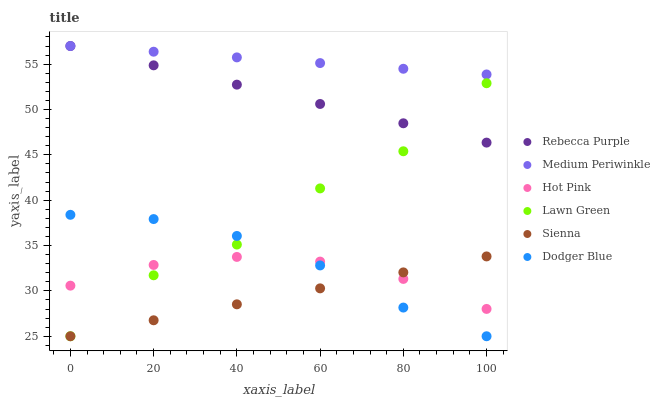Does Sienna have the minimum area under the curve?
Answer yes or no. Yes. Does Medium Periwinkle have the maximum area under the curve?
Answer yes or no. Yes. Does Hot Pink have the minimum area under the curve?
Answer yes or no. No. Does Hot Pink have the maximum area under the curve?
Answer yes or no. No. Is Rebecca Purple the smoothest?
Answer yes or no. Yes. Is Lawn Green the roughest?
Answer yes or no. Yes. Is Hot Pink the smoothest?
Answer yes or no. No. Is Hot Pink the roughest?
Answer yes or no. No. Does Lawn Green have the lowest value?
Answer yes or no. Yes. Does Hot Pink have the lowest value?
Answer yes or no. No. Does Rebecca Purple have the highest value?
Answer yes or no. Yes. Does Hot Pink have the highest value?
Answer yes or no. No. Is Hot Pink less than Rebecca Purple?
Answer yes or no. Yes. Is Rebecca Purple greater than Dodger Blue?
Answer yes or no. Yes. Does Sienna intersect Lawn Green?
Answer yes or no. Yes. Is Sienna less than Lawn Green?
Answer yes or no. No. Is Sienna greater than Lawn Green?
Answer yes or no. No. Does Hot Pink intersect Rebecca Purple?
Answer yes or no. No. 